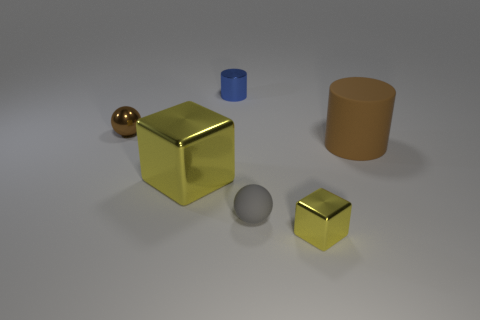Add 4 big brown rubber cylinders. How many objects exist? 10 Subtract all spheres. Subtract all brown metal spheres. How many objects are left? 3 Add 3 blue objects. How many blue objects are left? 4 Add 4 large yellow cylinders. How many large yellow cylinders exist? 4 Subtract 0 purple balls. How many objects are left? 6 